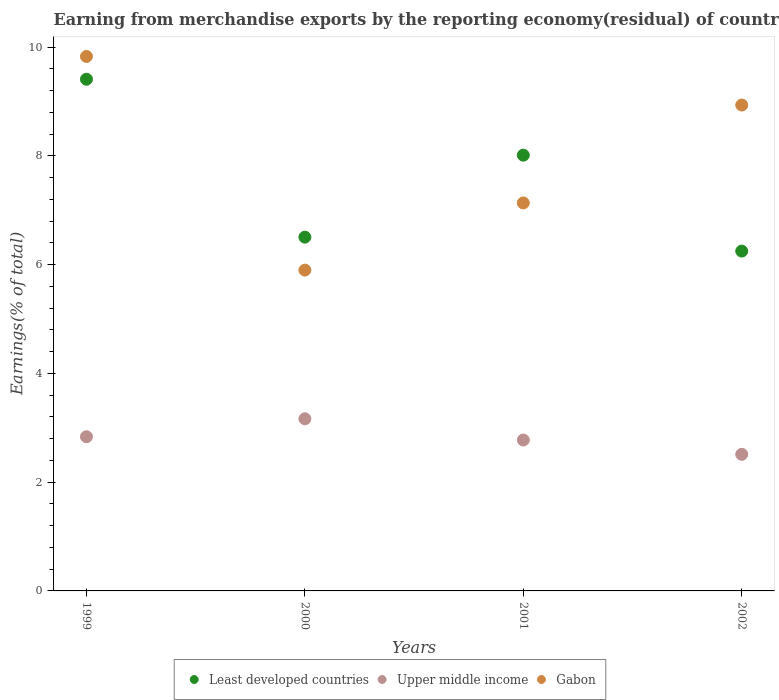Is the number of dotlines equal to the number of legend labels?
Your answer should be compact. Yes. What is the percentage of amount earned from merchandise exports in Gabon in 1999?
Provide a succinct answer. 9.83. Across all years, what is the maximum percentage of amount earned from merchandise exports in Gabon?
Offer a terse response. 9.83. Across all years, what is the minimum percentage of amount earned from merchandise exports in Least developed countries?
Ensure brevity in your answer.  6.25. In which year was the percentage of amount earned from merchandise exports in Upper middle income minimum?
Your answer should be compact. 2002. What is the total percentage of amount earned from merchandise exports in Upper middle income in the graph?
Offer a terse response. 11.29. What is the difference between the percentage of amount earned from merchandise exports in Least developed countries in 1999 and that in 2001?
Provide a short and direct response. 1.4. What is the difference between the percentage of amount earned from merchandise exports in Gabon in 2000 and the percentage of amount earned from merchandise exports in Least developed countries in 2001?
Keep it short and to the point. -2.11. What is the average percentage of amount earned from merchandise exports in Least developed countries per year?
Offer a terse response. 7.54. In the year 2002, what is the difference between the percentage of amount earned from merchandise exports in Upper middle income and percentage of amount earned from merchandise exports in Least developed countries?
Offer a very short reply. -3.74. In how many years, is the percentage of amount earned from merchandise exports in Gabon greater than 2.8 %?
Your response must be concise. 4. What is the ratio of the percentage of amount earned from merchandise exports in Gabon in 1999 to that in 2002?
Your response must be concise. 1.1. Is the difference between the percentage of amount earned from merchandise exports in Upper middle income in 2000 and 2001 greater than the difference between the percentage of amount earned from merchandise exports in Least developed countries in 2000 and 2001?
Your response must be concise. Yes. What is the difference between the highest and the second highest percentage of amount earned from merchandise exports in Least developed countries?
Your answer should be compact. 1.4. What is the difference between the highest and the lowest percentage of amount earned from merchandise exports in Gabon?
Make the answer very short. 3.93. Is it the case that in every year, the sum of the percentage of amount earned from merchandise exports in Gabon and percentage of amount earned from merchandise exports in Upper middle income  is greater than the percentage of amount earned from merchandise exports in Least developed countries?
Provide a succinct answer. Yes. Does the percentage of amount earned from merchandise exports in Gabon monotonically increase over the years?
Give a very brief answer. No. Is the percentage of amount earned from merchandise exports in Upper middle income strictly greater than the percentage of amount earned from merchandise exports in Least developed countries over the years?
Provide a succinct answer. No. What is the difference between two consecutive major ticks on the Y-axis?
Ensure brevity in your answer.  2. Are the values on the major ticks of Y-axis written in scientific E-notation?
Provide a short and direct response. No. Does the graph contain grids?
Your response must be concise. No. Where does the legend appear in the graph?
Keep it short and to the point. Bottom center. How many legend labels are there?
Your answer should be compact. 3. How are the legend labels stacked?
Give a very brief answer. Horizontal. What is the title of the graph?
Offer a terse response. Earning from merchandise exports by the reporting economy(residual) of countries. What is the label or title of the X-axis?
Your answer should be very brief. Years. What is the label or title of the Y-axis?
Provide a succinct answer. Earnings(% of total). What is the Earnings(% of total) in Least developed countries in 1999?
Provide a short and direct response. 9.41. What is the Earnings(% of total) of Upper middle income in 1999?
Offer a very short reply. 2.83. What is the Earnings(% of total) in Gabon in 1999?
Your answer should be very brief. 9.83. What is the Earnings(% of total) in Least developed countries in 2000?
Make the answer very short. 6.51. What is the Earnings(% of total) in Upper middle income in 2000?
Offer a very short reply. 3.17. What is the Earnings(% of total) of Gabon in 2000?
Your response must be concise. 5.9. What is the Earnings(% of total) of Least developed countries in 2001?
Make the answer very short. 8.01. What is the Earnings(% of total) of Upper middle income in 2001?
Ensure brevity in your answer.  2.77. What is the Earnings(% of total) of Gabon in 2001?
Make the answer very short. 7.13. What is the Earnings(% of total) of Least developed countries in 2002?
Provide a succinct answer. 6.25. What is the Earnings(% of total) of Upper middle income in 2002?
Your response must be concise. 2.51. What is the Earnings(% of total) in Gabon in 2002?
Provide a short and direct response. 8.93. Across all years, what is the maximum Earnings(% of total) of Least developed countries?
Provide a short and direct response. 9.41. Across all years, what is the maximum Earnings(% of total) in Upper middle income?
Offer a terse response. 3.17. Across all years, what is the maximum Earnings(% of total) of Gabon?
Provide a succinct answer. 9.83. Across all years, what is the minimum Earnings(% of total) of Least developed countries?
Give a very brief answer. 6.25. Across all years, what is the minimum Earnings(% of total) of Upper middle income?
Keep it short and to the point. 2.51. Across all years, what is the minimum Earnings(% of total) in Gabon?
Ensure brevity in your answer.  5.9. What is the total Earnings(% of total) in Least developed countries in the graph?
Offer a very short reply. 30.18. What is the total Earnings(% of total) in Upper middle income in the graph?
Ensure brevity in your answer.  11.29. What is the total Earnings(% of total) of Gabon in the graph?
Your response must be concise. 31.8. What is the difference between the Earnings(% of total) in Least developed countries in 1999 and that in 2000?
Your response must be concise. 2.9. What is the difference between the Earnings(% of total) in Upper middle income in 1999 and that in 2000?
Provide a succinct answer. -0.33. What is the difference between the Earnings(% of total) of Gabon in 1999 and that in 2000?
Give a very brief answer. 3.93. What is the difference between the Earnings(% of total) in Least developed countries in 1999 and that in 2001?
Provide a short and direct response. 1.4. What is the difference between the Earnings(% of total) in Upper middle income in 1999 and that in 2001?
Make the answer very short. 0.06. What is the difference between the Earnings(% of total) in Gabon in 1999 and that in 2001?
Make the answer very short. 2.69. What is the difference between the Earnings(% of total) of Least developed countries in 1999 and that in 2002?
Keep it short and to the point. 3.16. What is the difference between the Earnings(% of total) of Upper middle income in 1999 and that in 2002?
Offer a terse response. 0.32. What is the difference between the Earnings(% of total) in Gabon in 1999 and that in 2002?
Provide a succinct answer. 0.89. What is the difference between the Earnings(% of total) of Least developed countries in 2000 and that in 2001?
Offer a very short reply. -1.51. What is the difference between the Earnings(% of total) of Upper middle income in 2000 and that in 2001?
Provide a short and direct response. 0.39. What is the difference between the Earnings(% of total) of Gabon in 2000 and that in 2001?
Provide a short and direct response. -1.24. What is the difference between the Earnings(% of total) of Least developed countries in 2000 and that in 2002?
Ensure brevity in your answer.  0.26. What is the difference between the Earnings(% of total) in Upper middle income in 2000 and that in 2002?
Offer a terse response. 0.65. What is the difference between the Earnings(% of total) of Gabon in 2000 and that in 2002?
Offer a terse response. -3.04. What is the difference between the Earnings(% of total) in Least developed countries in 2001 and that in 2002?
Ensure brevity in your answer.  1.76. What is the difference between the Earnings(% of total) in Upper middle income in 2001 and that in 2002?
Give a very brief answer. 0.26. What is the difference between the Earnings(% of total) in Gabon in 2001 and that in 2002?
Your answer should be very brief. -1.8. What is the difference between the Earnings(% of total) of Least developed countries in 1999 and the Earnings(% of total) of Upper middle income in 2000?
Your answer should be compact. 6.24. What is the difference between the Earnings(% of total) of Least developed countries in 1999 and the Earnings(% of total) of Gabon in 2000?
Make the answer very short. 3.51. What is the difference between the Earnings(% of total) of Upper middle income in 1999 and the Earnings(% of total) of Gabon in 2000?
Give a very brief answer. -3.06. What is the difference between the Earnings(% of total) of Least developed countries in 1999 and the Earnings(% of total) of Upper middle income in 2001?
Make the answer very short. 6.63. What is the difference between the Earnings(% of total) of Least developed countries in 1999 and the Earnings(% of total) of Gabon in 2001?
Ensure brevity in your answer.  2.27. What is the difference between the Earnings(% of total) of Upper middle income in 1999 and the Earnings(% of total) of Gabon in 2001?
Your answer should be very brief. -4.3. What is the difference between the Earnings(% of total) of Least developed countries in 1999 and the Earnings(% of total) of Upper middle income in 2002?
Offer a terse response. 6.9. What is the difference between the Earnings(% of total) in Least developed countries in 1999 and the Earnings(% of total) in Gabon in 2002?
Offer a very short reply. 0.47. What is the difference between the Earnings(% of total) of Upper middle income in 1999 and the Earnings(% of total) of Gabon in 2002?
Ensure brevity in your answer.  -6.1. What is the difference between the Earnings(% of total) of Least developed countries in 2000 and the Earnings(% of total) of Upper middle income in 2001?
Your answer should be very brief. 3.73. What is the difference between the Earnings(% of total) of Least developed countries in 2000 and the Earnings(% of total) of Gabon in 2001?
Your response must be concise. -0.63. What is the difference between the Earnings(% of total) of Upper middle income in 2000 and the Earnings(% of total) of Gabon in 2001?
Keep it short and to the point. -3.97. What is the difference between the Earnings(% of total) in Least developed countries in 2000 and the Earnings(% of total) in Upper middle income in 2002?
Give a very brief answer. 3.99. What is the difference between the Earnings(% of total) in Least developed countries in 2000 and the Earnings(% of total) in Gabon in 2002?
Your answer should be very brief. -2.43. What is the difference between the Earnings(% of total) of Upper middle income in 2000 and the Earnings(% of total) of Gabon in 2002?
Provide a succinct answer. -5.77. What is the difference between the Earnings(% of total) in Least developed countries in 2001 and the Earnings(% of total) in Upper middle income in 2002?
Your answer should be compact. 5.5. What is the difference between the Earnings(% of total) of Least developed countries in 2001 and the Earnings(% of total) of Gabon in 2002?
Give a very brief answer. -0.92. What is the difference between the Earnings(% of total) of Upper middle income in 2001 and the Earnings(% of total) of Gabon in 2002?
Provide a succinct answer. -6.16. What is the average Earnings(% of total) of Least developed countries per year?
Provide a succinct answer. 7.54. What is the average Earnings(% of total) of Upper middle income per year?
Make the answer very short. 2.82. What is the average Earnings(% of total) of Gabon per year?
Make the answer very short. 7.95. In the year 1999, what is the difference between the Earnings(% of total) of Least developed countries and Earnings(% of total) of Upper middle income?
Your answer should be very brief. 6.57. In the year 1999, what is the difference between the Earnings(% of total) in Least developed countries and Earnings(% of total) in Gabon?
Provide a short and direct response. -0.42. In the year 1999, what is the difference between the Earnings(% of total) of Upper middle income and Earnings(% of total) of Gabon?
Give a very brief answer. -6.99. In the year 2000, what is the difference between the Earnings(% of total) in Least developed countries and Earnings(% of total) in Upper middle income?
Keep it short and to the point. 3.34. In the year 2000, what is the difference between the Earnings(% of total) of Least developed countries and Earnings(% of total) of Gabon?
Your answer should be compact. 0.61. In the year 2000, what is the difference between the Earnings(% of total) of Upper middle income and Earnings(% of total) of Gabon?
Provide a succinct answer. -2.73. In the year 2001, what is the difference between the Earnings(% of total) of Least developed countries and Earnings(% of total) of Upper middle income?
Offer a very short reply. 5.24. In the year 2001, what is the difference between the Earnings(% of total) of Least developed countries and Earnings(% of total) of Gabon?
Your response must be concise. 0.88. In the year 2001, what is the difference between the Earnings(% of total) in Upper middle income and Earnings(% of total) in Gabon?
Give a very brief answer. -4.36. In the year 2002, what is the difference between the Earnings(% of total) of Least developed countries and Earnings(% of total) of Upper middle income?
Your answer should be very brief. 3.74. In the year 2002, what is the difference between the Earnings(% of total) of Least developed countries and Earnings(% of total) of Gabon?
Give a very brief answer. -2.69. In the year 2002, what is the difference between the Earnings(% of total) in Upper middle income and Earnings(% of total) in Gabon?
Offer a terse response. -6.42. What is the ratio of the Earnings(% of total) in Least developed countries in 1999 to that in 2000?
Your answer should be very brief. 1.45. What is the ratio of the Earnings(% of total) of Upper middle income in 1999 to that in 2000?
Your answer should be very brief. 0.9. What is the ratio of the Earnings(% of total) in Gabon in 1999 to that in 2000?
Your answer should be very brief. 1.67. What is the ratio of the Earnings(% of total) of Least developed countries in 1999 to that in 2001?
Ensure brevity in your answer.  1.17. What is the ratio of the Earnings(% of total) of Upper middle income in 1999 to that in 2001?
Make the answer very short. 1.02. What is the ratio of the Earnings(% of total) in Gabon in 1999 to that in 2001?
Your answer should be very brief. 1.38. What is the ratio of the Earnings(% of total) in Least developed countries in 1999 to that in 2002?
Make the answer very short. 1.51. What is the ratio of the Earnings(% of total) in Upper middle income in 1999 to that in 2002?
Give a very brief answer. 1.13. What is the ratio of the Earnings(% of total) in Gabon in 1999 to that in 2002?
Make the answer very short. 1.1. What is the ratio of the Earnings(% of total) of Least developed countries in 2000 to that in 2001?
Your response must be concise. 0.81. What is the ratio of the Earnings(% of total) of Upper middle income in 2000 to that in 2001?
Keep it short and to the point. 1.14. What is the ratio of the Earnings(% of total) of Gabon in 2000 to that in 2001?
Provide a short and direct response. 0.83. What is the ratio of the Earnings(% of total) of Least developed countries in 2000 to that in 2002?
Provide a short and direct response. 1.04. What is the ratio of the Earnings(% of total) of Upper middle income in 2000 to that in 2002?
Keep it short and to the point. 1.26. What is the ratio of the Earnings(% of total) in Gabon in 2000 to that in 2002?
Provide a short and direct response. 0.66. What is the ratio of the Earnings(% of total) in Least developed countries in 2001 to that in 2002?
Offer a very short reply. 1.28. What is the ratio of the Earnings(% of total) in Upper middle income in 2001 to that in 2002?
Keep it short and to the point. 1.1. What is the ratio of the Earnings(% of total) in Gabon in 2001 to that in 2002?
Provide a succinct answer. 0.8. What is the difference between the highest and the second highest Earnings(% of total) of Least developed countries?
Ensure brevity in your answer.  1.4. What is the difference between the highest and the second highest Earnings(% of total) in Upper middle income?
Your answer should be compact. 0.33. What is the difference between the highest and the second highest Earnings(% of total) in Gabon?
Offer a very short reply. 0.89. What is the difference between the highest and the lowest Earnings(% of total) in Least developed countries?
Your answer should be compact. 3.16. What is the difference between the highest and the lowest Earnings(% of total) of Upper middle income?
Your answer should be very brief. 0.65. What is the difference between the highest and the lowest Earnings(% of total) in Gabon?
Offer a very short reply. 3.93. 